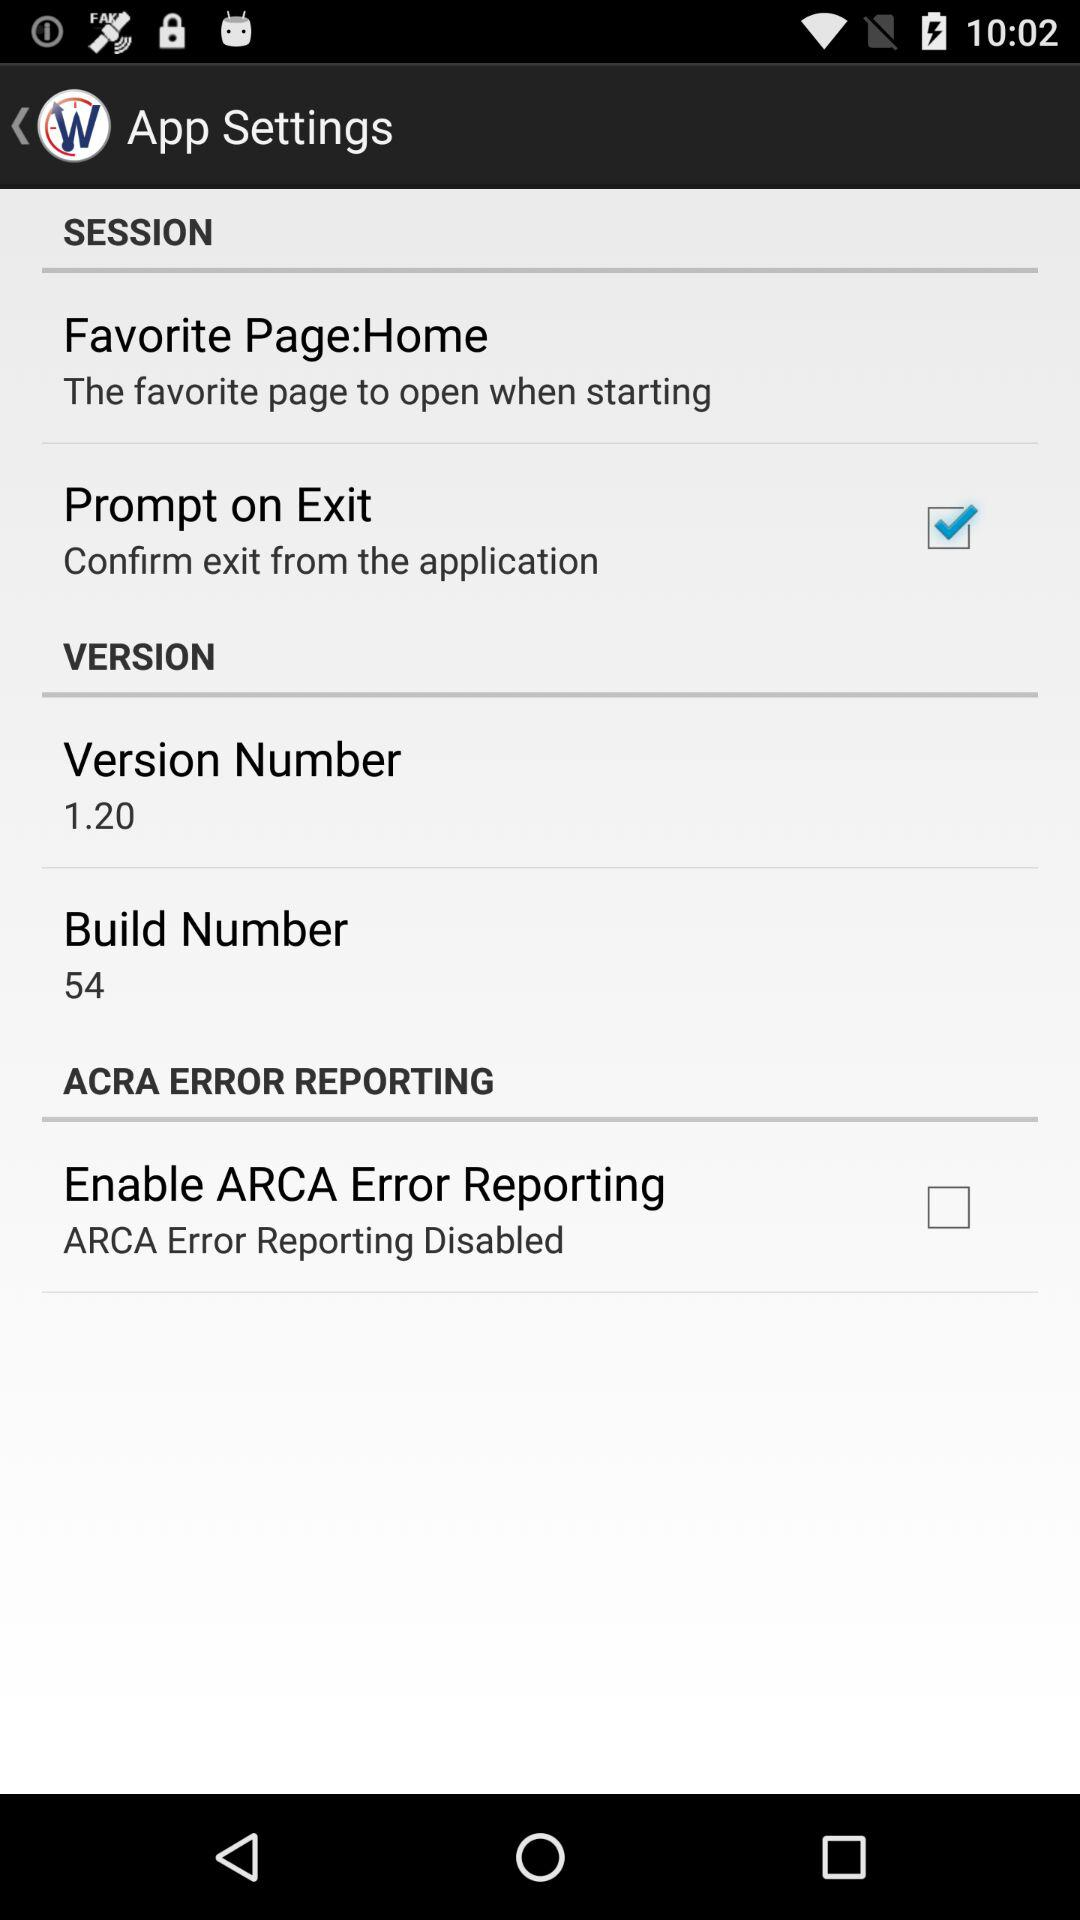What is the status of the "Prompt on Exit" setting? The status is "on". 